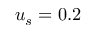<formula> <loc_0><loc_0><loc_500><loc_500>u _ { s } = 0 . 2</formula> 